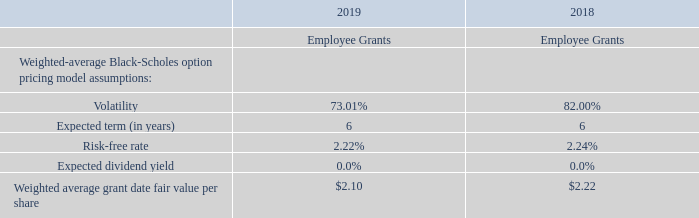The Company estimates the fair values of stock options using the Black-Scholes option-pricing model on the date of grant.For the years ended December 31, 2019 and 2018, the assumptions used in the Black-Scholes option pricing model, which was used to estimate the grant date fair value per option, were as follows:
The risk-free interest rate is the United States Treasury rate for the day of the grant having a term equal to the life of the equity instrument. The volatility is a measure of the amount by which the Company’s share price has fluctuated or is expected to fluctuate; the Company used its common stock volatility along with the average of historic volatilities of comparative companies. The dividend yield is zero as the Company has not made any dividend payment and has no plans to pay dividends in the foreseeable future. The Company determines the expected term of its stock option awards by using the simplified method, which assumes each vesting tranche of the award has a term equal to average of the contractual term and the vesting period.
As of December 31, 2019, total compensation cost not yet recognized related to unvested stock options was approximately $0.8 million, which is expected to be recognized over a weighted-average period of 2.3 years.
What are the respective expected terms of the 2018 and 2019 employee grants? 6, 6. What are the respective volatility of the 2018 and 2019 employee grants? 82.00%, 73.01%. What are the respective risk-free rate of the 2018 and 2019 employee grants? 2.24%, 2.22%. What is the average expected dividend yield of the 2018 and 2019 employee grants?
Answer scale should be: percent. ( 0 + 0)/2 
Answer: 0. What is the average risk-free rate in 2018 and 2019?
Answer scale should be: percent. (2.24 + 2.22)/2 
Answer: 2.23. What is the average volatility in 2018 and 2019?
Answer scale should be: percent. (73.01 + 82.00)/2 
Answer: 77.51. 